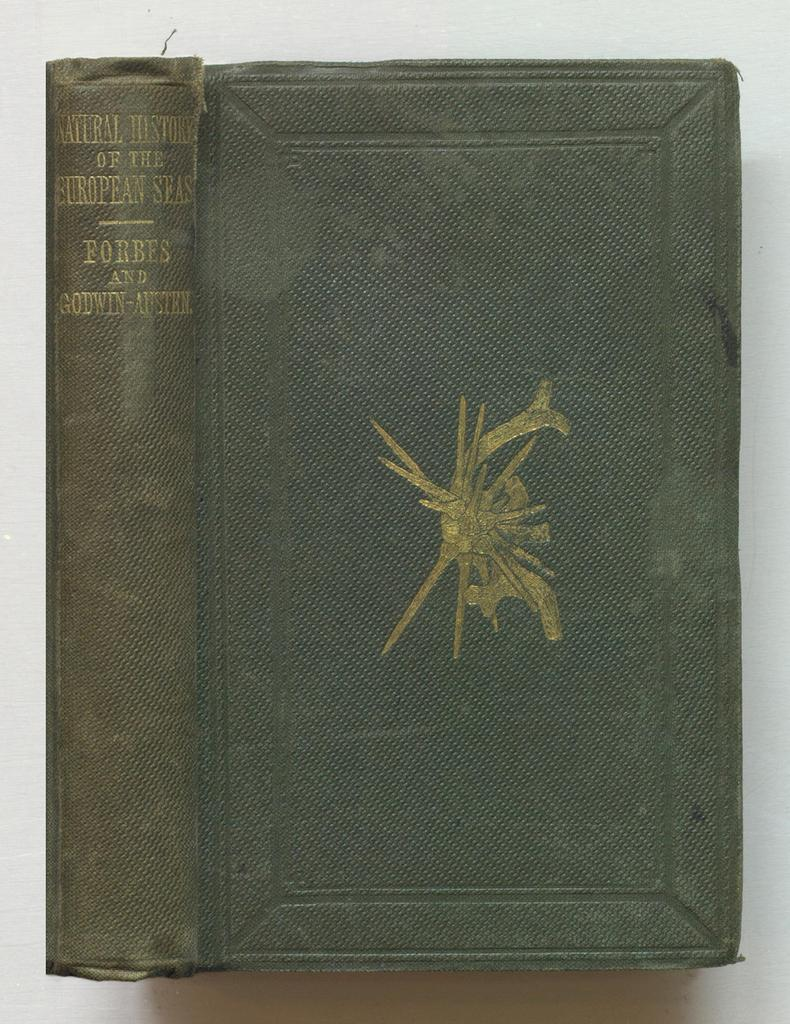<image>
Offer a succinct explanation of the picture presented. An old green textbook titled Natural History of the European Seas on it. 